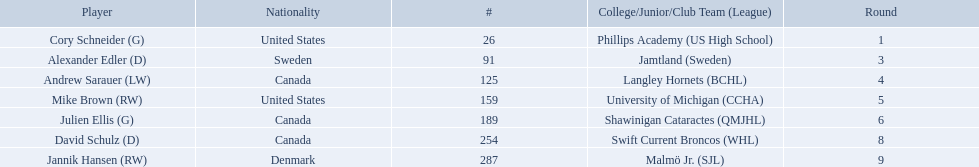Parse the full table in json format. {'header': ['Player', 'Nationality', '#', 'College/Junior/Club Team (League)', 'Round'], 'rows': [['Cory Schneider (G)', 'United States', '26', 'Phillips Academy (US High School)', '1'], ['Alexander Edler (D)', 'Sweden', '91', 'Jamtland (Sweden)', '3'], ['Andrew Sarauer (LW)', 'Canada', '125', 'Langley Hornets (BCHL)', '4'], ['Mike Brown (RW)', 'United States', '159', 'University of Michigan (CCHA)', '5'], ['Julien Ellis (G)', 'Canada', '189', 'Shawinigan Cataractes (QMJHL)', '6'], ['David Schulz (D)', 'Canada', '254', 'Swift Current Broncos (WHL)', '8'], ['Jannik Hansen (RW)', 'Denmark', '287', 'Malmö Jr. (SJL)', '9']]} Which players have canadian nationality? Andrew Sarauer (LW), Julien Ellis (G), David Schulz (D). Of those, which attended langley hornets? Andrew Sarauer (LW). 